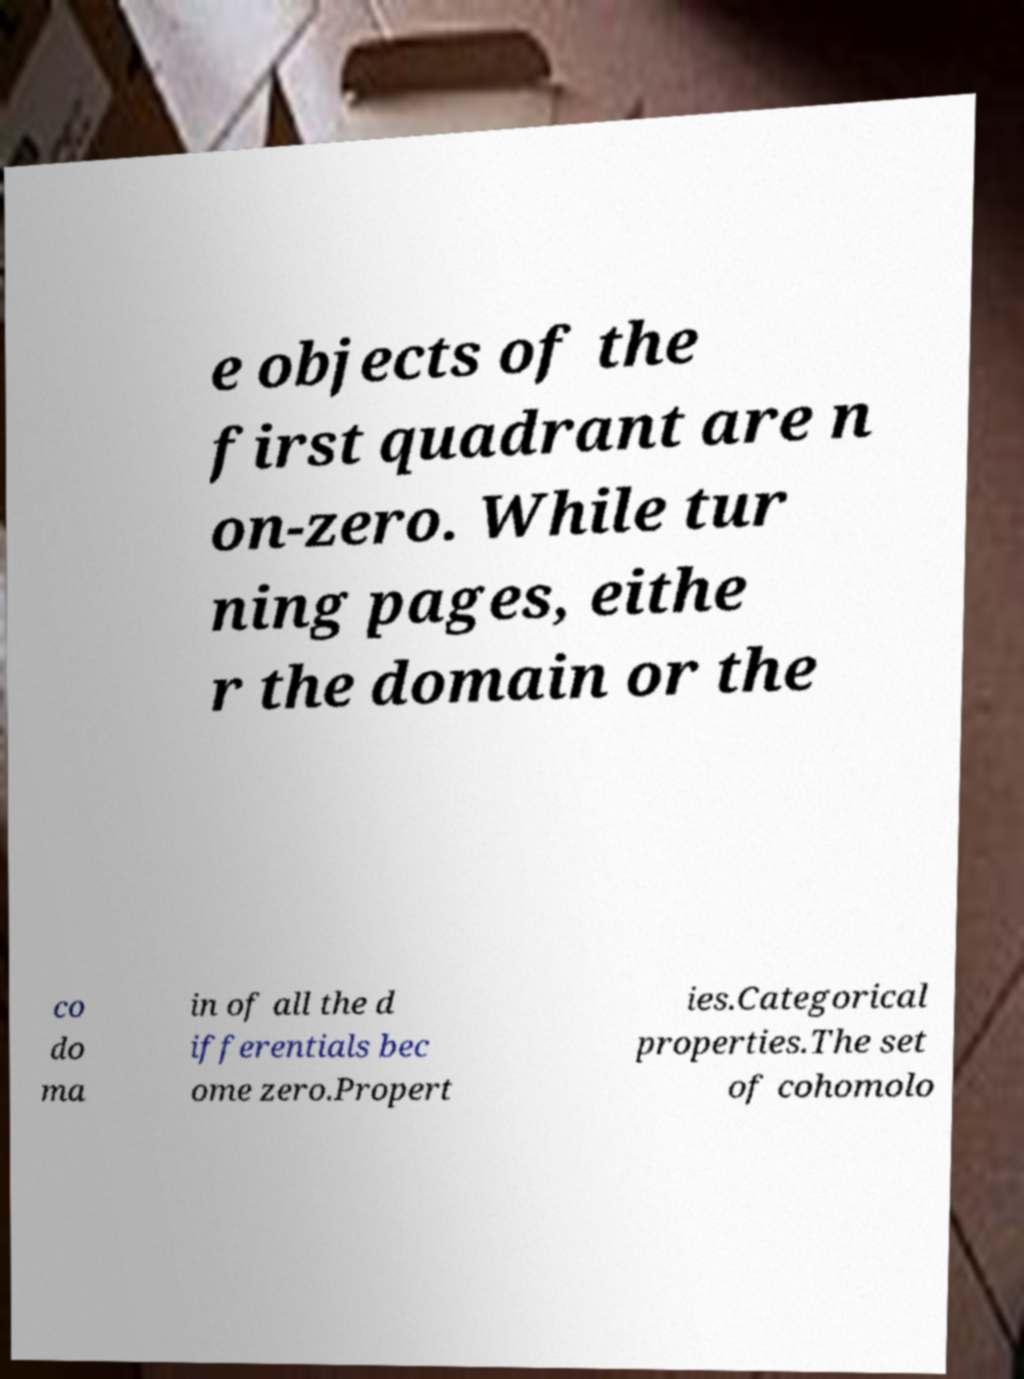I need the written content from this picture converted into text. Can you do that? e objects of the first quadrant are n on-zero. While tur ning pages, eithe r the domain or the co do ma in of all the d ifferentials bec ome zero.Propert ies.Categorical properties.The set of cohomolo 